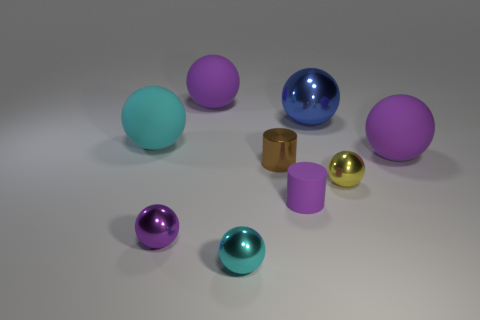Subtract all purple spheres. How many were subtracted if there are2purple spheres left? 1 Subtract all red cylinders. How many purple spheres are left? 3 Subtract 2 balls. How many balls are left? 5 Subtract all blue balls. How many balls are left? 6 Subtract all blue spheres. How many spheres are left? 6 Subtract all gray balls. Subtract all green cylinders. How many balls are left? 7 Add 1 tiny yellow balls. How many objects exist? 10 Subtract all spheres. How many objects are left? 2 Subtract 2 cyan balls. How many objects are left? 7 Subtract all blue cylinders. Subtract all big objects. How many objects are left? 5 